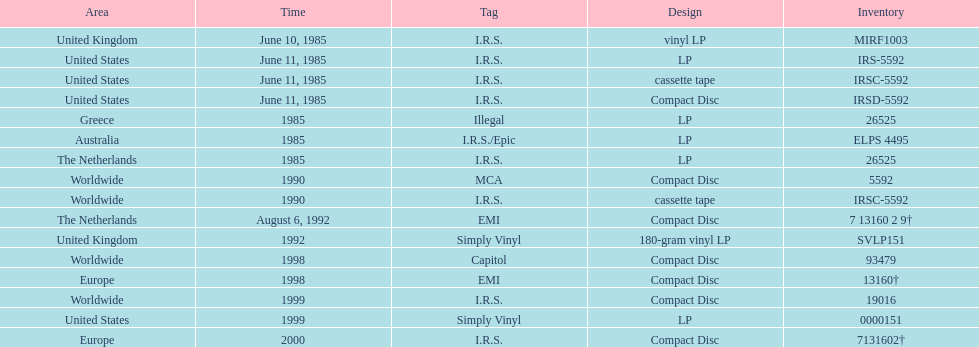Name at least two labels that released the group's albums. I.R.S., Illegal. 